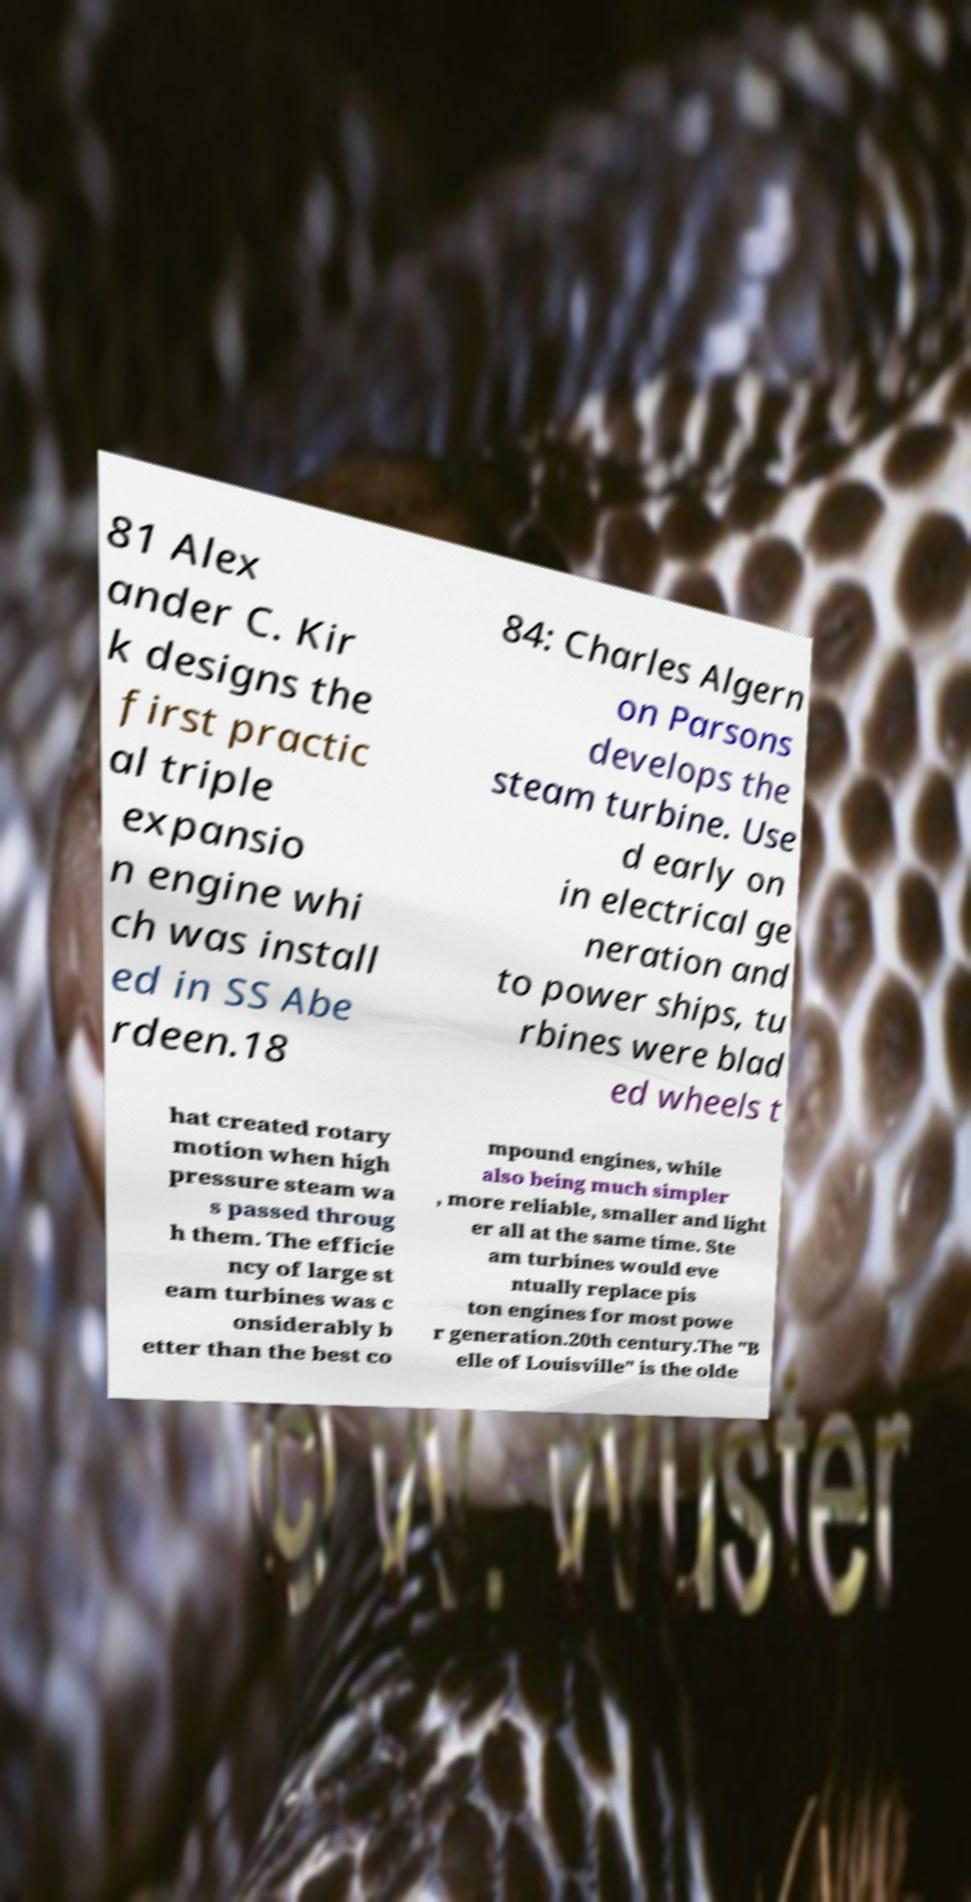I need the written content from this picture converted into text. Can you do that? 81 Alex ander C. Kir k designs the first practic al triple expansio n engine whi ch was install ed in SS Abe rdeen.18 84: Charles Algern on Parsons develops the steam turbine. Use d early on in electrical ge neration and to power ships, tu rbines were blad ed wheels t hat created rotary motion when high pressure steam wa s passed throug h them. The efficie ncy of large st eam turbines was c onsiderably b etter than the best co mpound engines, while also being much simpler , more reliable, smaller and light er all at the same time. Ste am turbines would eve ntually replace pis ton engines for most powe r generation.20th century.The "B elle of Louisville" is the olde 